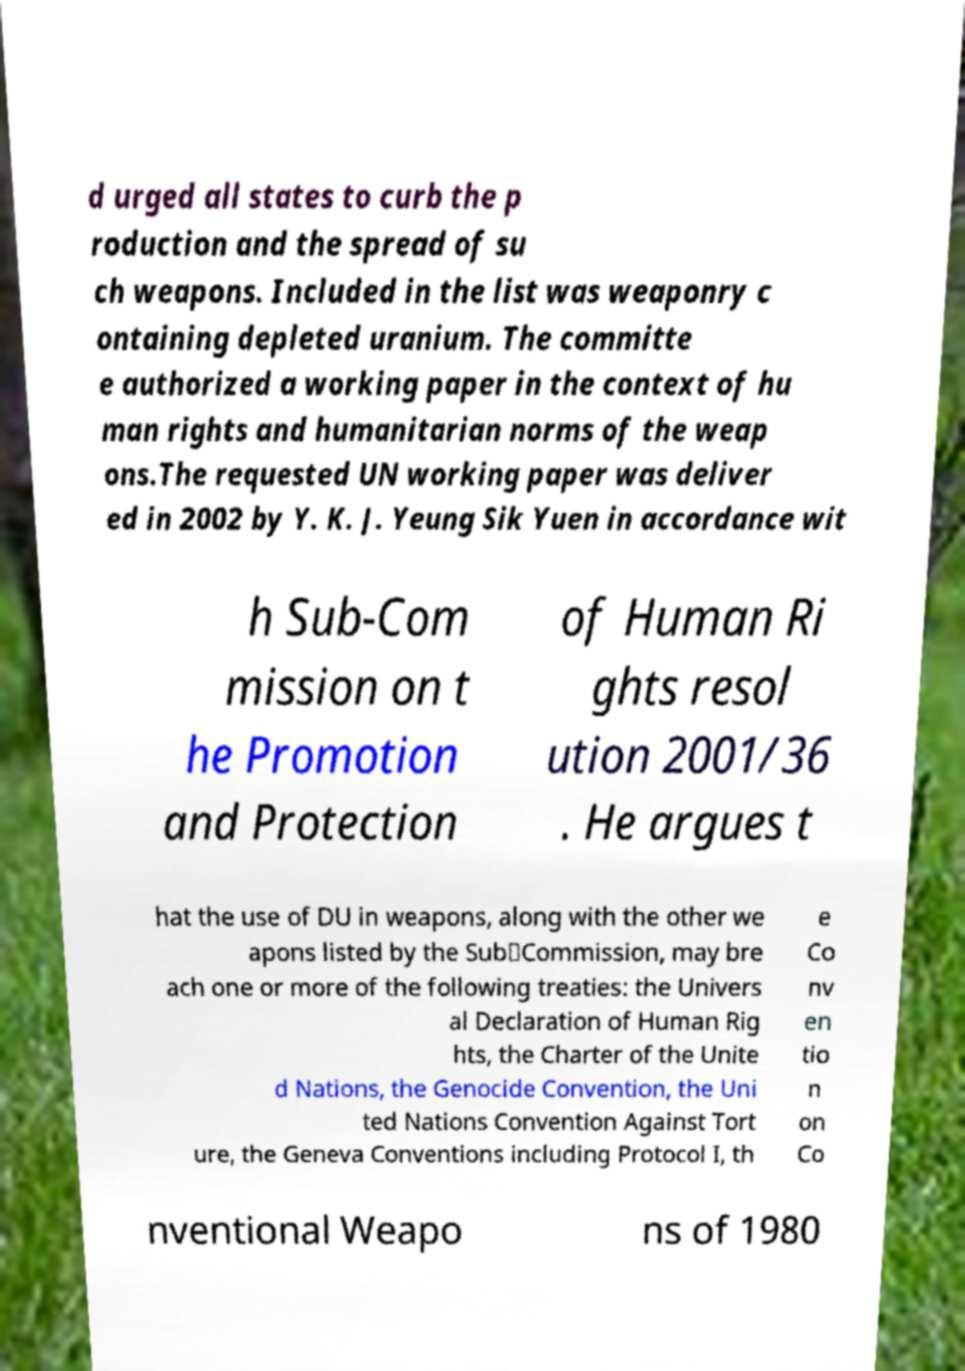Can you accurately transcribe the text from the provided image for me? d urged all states to curb the p roduction and the spread of su ch weapons. Included in the list was weaponry c ontaining depleted uranium. The committe e authorized a working paper in the context of hu man rights and humanitarian norms of the weap ons.The requested UN working paper was deliver ed in 2002 by Y. K. J. Yeung Sik Yuen in accordance wit h Sub-Com mission on t he Promotion and Protection of Human Ri ghts resol ution 2001/36 . He argues t hat the use of DU in weapons, along with the other we apons listed by the Sub‑Commission, may bre ach one or more of the following treaties: the Univers al Declaration of Human Rig hts, the Charter of the Unite d Nations, the Genocide Convention, the Uni ted Nations Convention Against Tort ure, the Geneva Conventions including Protocol I, th e Co nv en tio n on Co nventional Weapo ns of 1980 